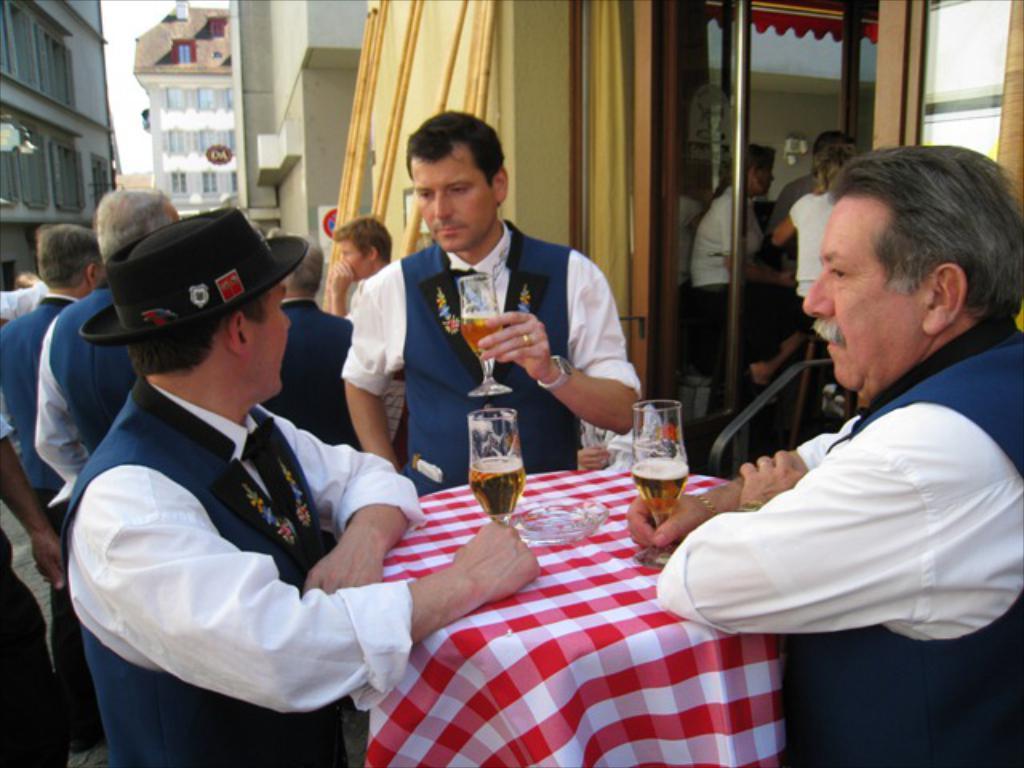Could you give a brief overview of what you see in this image? There are three people standing in front of a table and holding a wine glass in there hands and there are group of people and buildings behind them. 